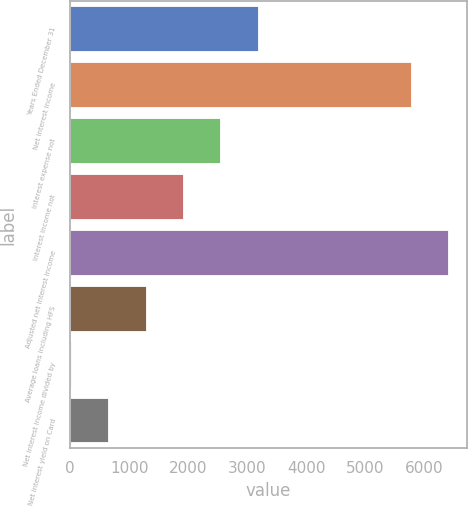Convert chart. <chart><loc_0><loc_0><loc_500><loc_500><bar_chart><fcel>Years Ended December 31<fcel>Net interest income<fcel>Interest expense not<fcel>Interest income not<fcel>Adjusted net interest income<fcel>Average loans including HFS<fcel>Net interest income divided by<fcel>Net interest yield on Card<nl><fcel>3180.4<fcel>5771<fcel>2546.08<fcel>1911.76<fcel>6405.32<fcel>1277.44<fcel>8.8<fcel>643.12<nl></chart> 